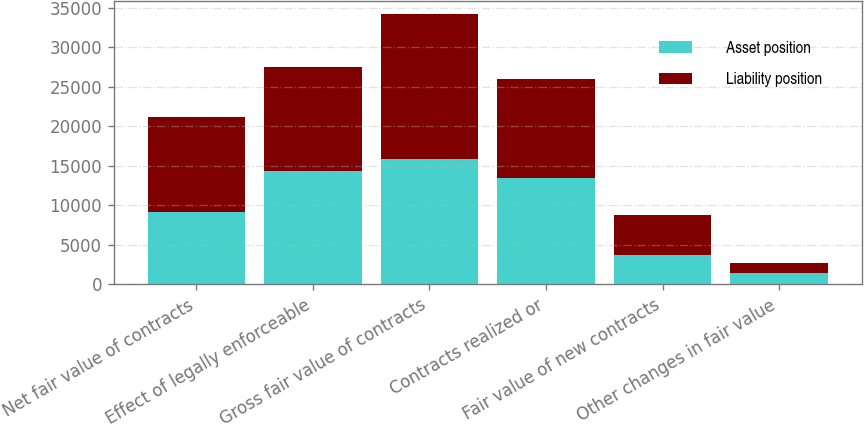<chart> <loc_0><loc_0><loc_500><loc_500><stacked_bar_chart><ecel><fcel>Net fair value of contracts<fcel>Effect of legally enforceable<fcel>Gross fair value of contracts<fcel>Contracts realized or<fcel>Fair value of new contracts<fcel>Other changes in fair value<nl><fcel>Asset position<fcel>9094<fcel>14327<fcel>15866<fcel>13419<fcel>3704<fcel>1428<nl><fcel>Liability position<fcel>12025<fcel>13211<fcel>18281<fcel>12583<fcel>5027<fcel>1300<nl></chart> 